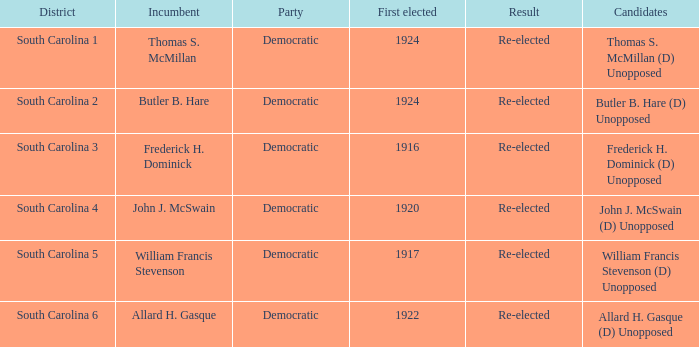What is the total number of results where the district is south carolina 5? 1.0. 